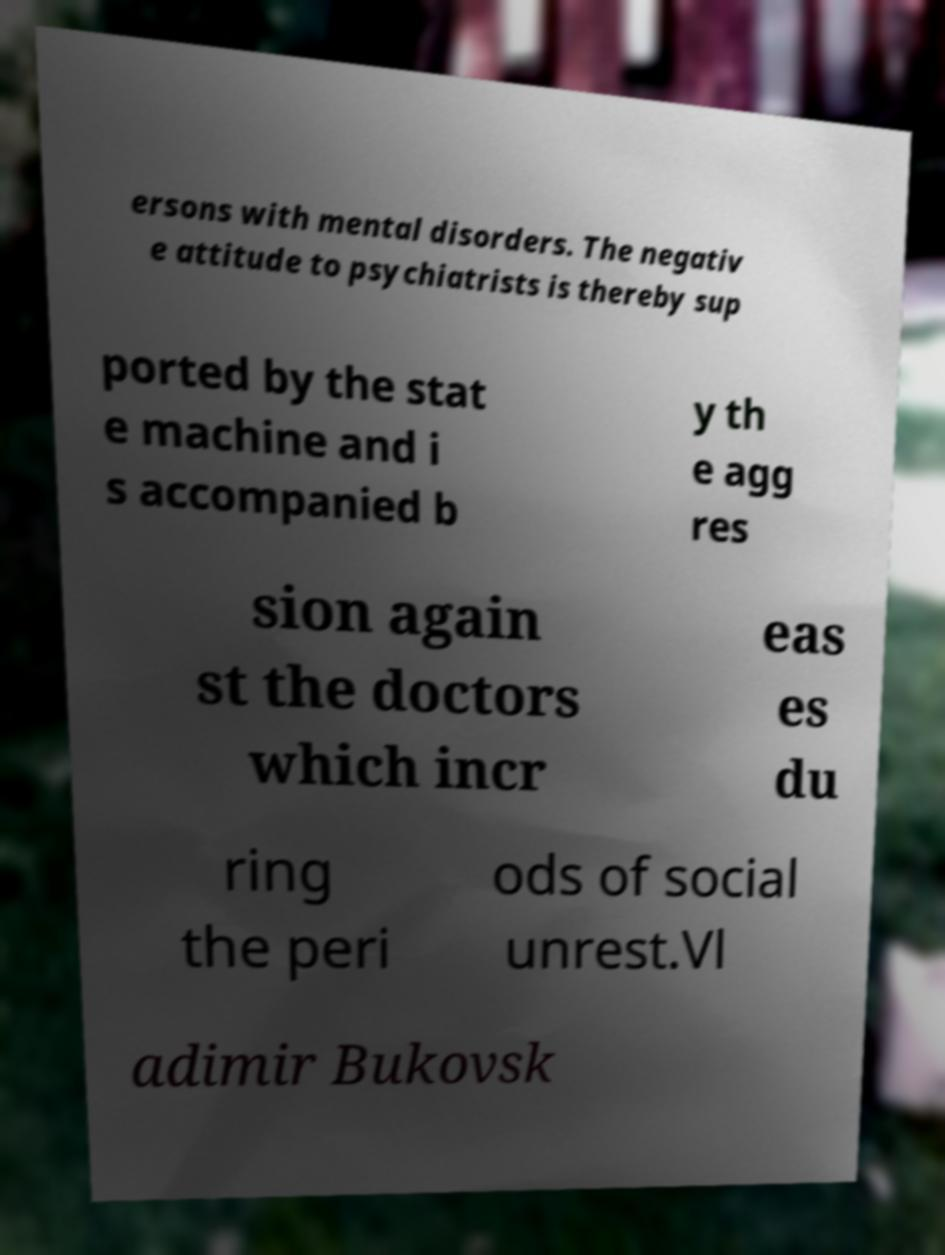Could you extract and type out the text from this image? ersons with mental disorders. The negativ e attitude to psychiatrists is thereby sup ported by the stat e machine and i s accompanied b y th e agg res sion again st the doctors which incr eas es du ring the peri ods of social unrest.Vl adimir Bukovsk 